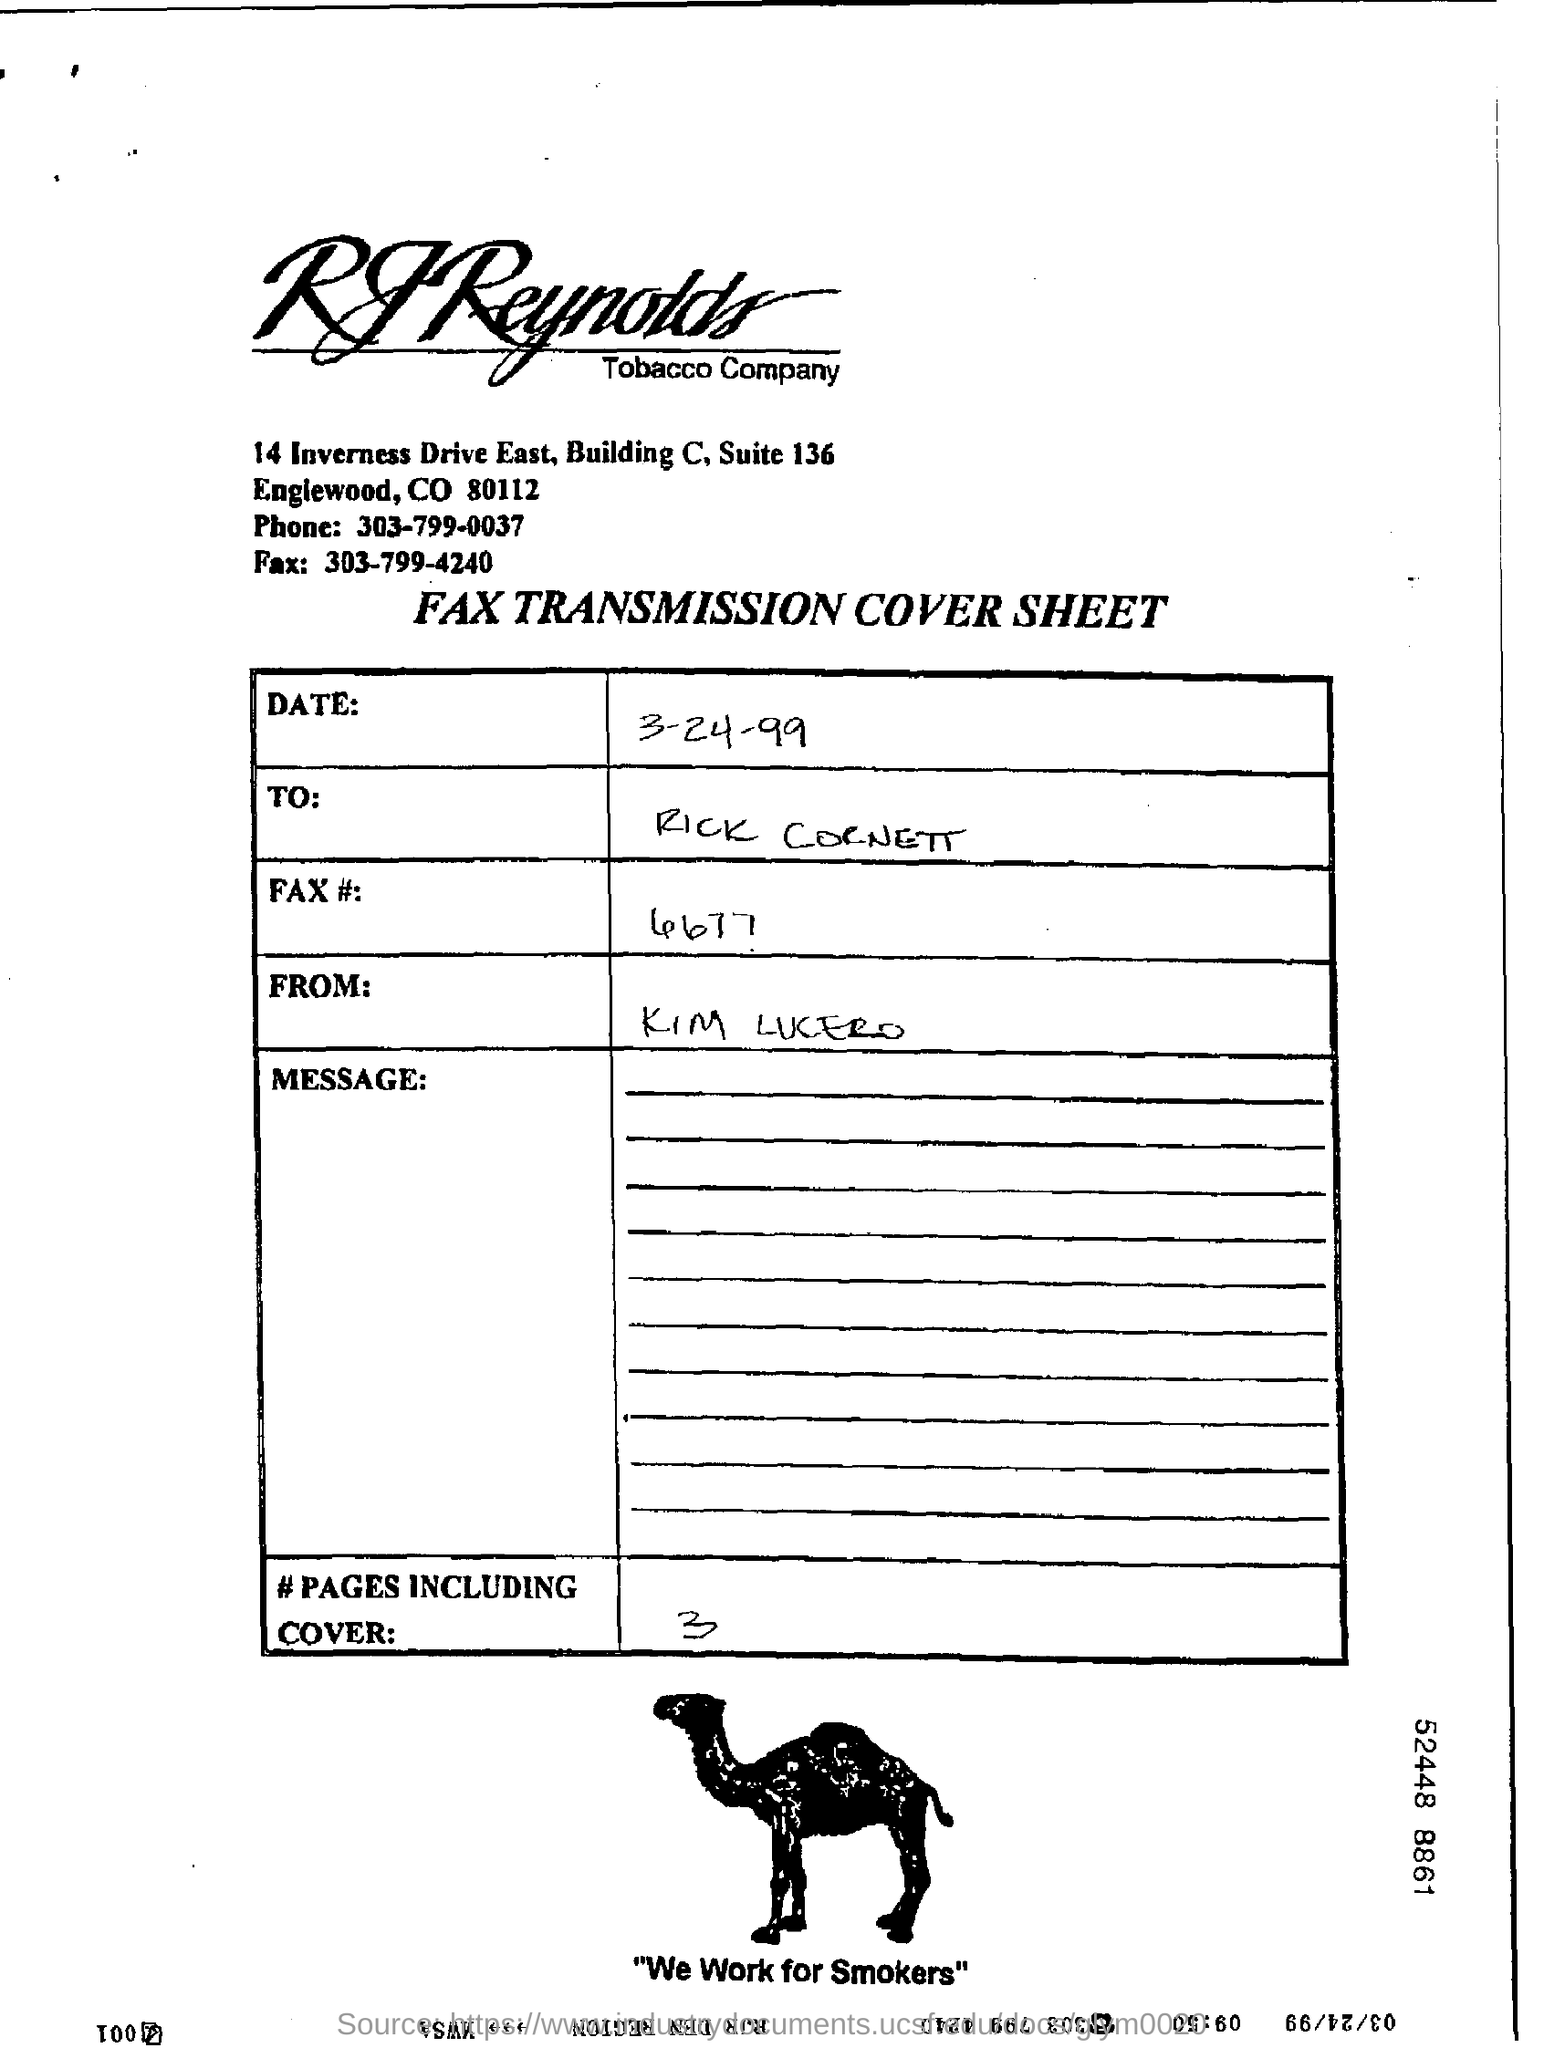List a handful of essential elements in this visual. The cover sheet is being sent to Rick Cornett. The RJ Reynolds Tobacco Company is the name of the company. 